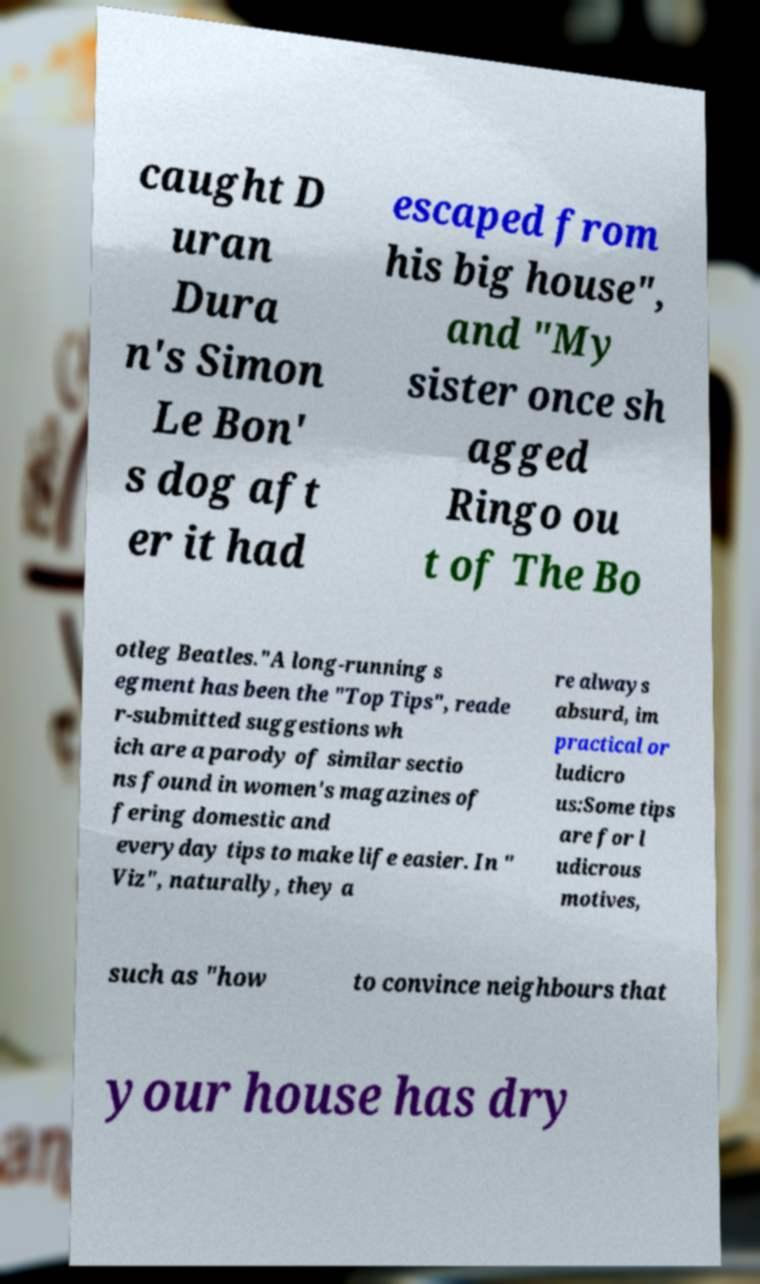Please read and relay the text visible in this image. What does it say? caught D uran Dura n's Simon Le Bon' s dog aft er it had escaped from his big house", and "My sister once sh agged Ringo ou t of The Bo otleg Beatles."A long-running s egment has been the "Top Tips", reade r-submitted suggestions wh ich are a parody of similar sectio ns found in women's magazines of fering domestic and everyday tips to make life easier. In " Viz", naturally, they a re always absurd, im practical or ludicro us:Some tips are for l udicrous motives, such as "how to convince neighbours that your house has dry 